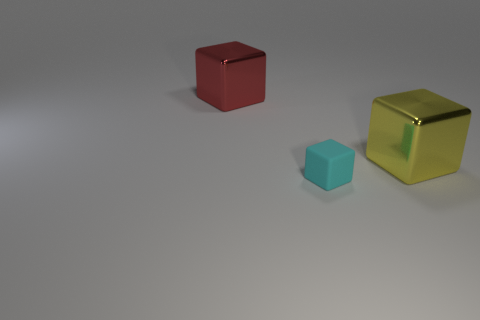Are there any other things that are made of the same material as the cyan cube?
Keep it short and to the point. No. Is there a yellow cube behind the metallic cube that is to the right of the big red metal block?
Provide a succinct answer. No. Are there an equal number of small cyan things that are right of the cyan object and red cubes?
Provide a succinct answer. No. What number of other objects are there of the same size as the yellow cube?
Provide a short and direct response. 1. Is the object that is left of the small rubber thing made of the same material as the cube in front of the large yellow metallic object?
Offer a terse response. No. There is a shiny block that is in front of the thing that is to the left of the small cyan cube; what is its size?
Offer a very short reply. Large. Are there any other matte cubes that have the same color as the tiny rubber cube?
Keep it short and to the point. No. The yellow thing is what shape?
Give a very brief answer. Cube. What number of large objects are in front of the big red metallic thing?
Your response must be concise. 1. What number of cyan blocks have the same material as the large yellow object?
Ensure brevity in your answer.  0. 